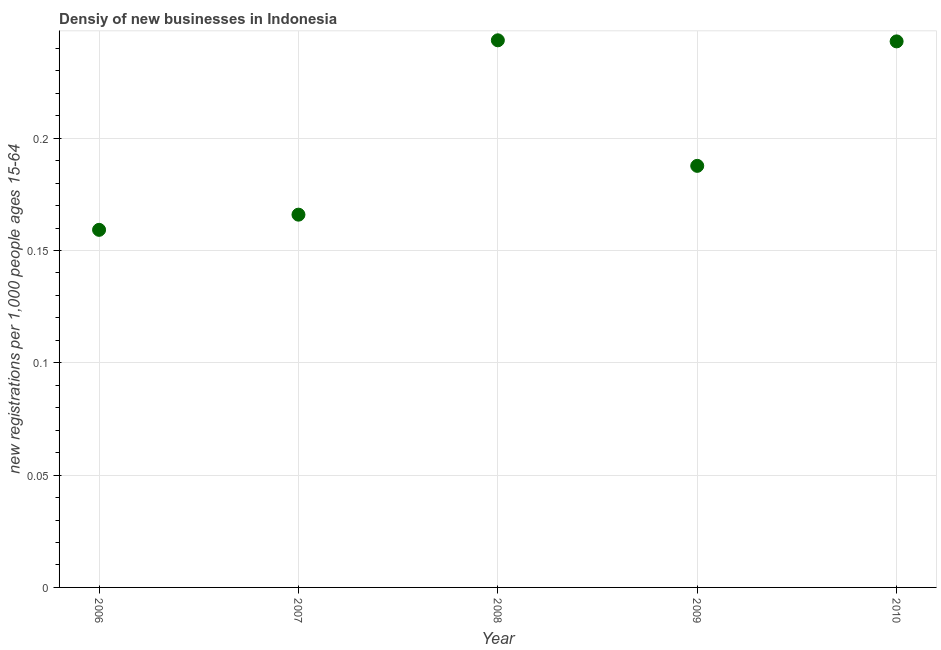What is the density of new business in 2010?
Your answer should be very brief. 0.24. Across all years, what is the maximum density of new business?
Provide a succinct answer. 0.24. Across all years, what is the minimum density of new business?
Keep it short and to the point. 0.16. In which year was the density of new business maximum?
Provide a succinct answer. 2008. What is the sum of the density of new business?
Make the answer very short. 1. What is the difference between the density of new business in 2006 and 2007?
Ensure brevity in your answer.  -0.01. What is the average density of new business per year?
Offer a very short reply. 0.2. What is the median density of new business?
Ensure brevity in your answer.  0.19. What is the ratio of the density of new business in 2007 to that in 2009?
Your answer should be compact. 0.88. Is the difference between the density of new business in 2006 and 2010 greater than the difference between any two years?
Ensure brevity in your answer.  No. What is the difference between the highest and the second highest density of new business?
Offer a terse response. 0. Is the sum of the density of new business in 2006 and 2010 greater than the maximum density of new business across all years?
Your response must be concise. Yes. What is the difference between the highest and the lowest density of new business?
Keep it short and to the point. 0.08. How many years are there in the graph?
Provide a succinct answer. 5. Are the values on the major ticks of Y-axis written in scientific E-notation?
Keep it short and to the point. No. Does the graph contain grids?
Offer a terse response. Yes. What is the title of the graph?
Your answer should be compact. Densiy of new businesses in Indonesia. What is the label or title of the X-axis?
Provide a short and direct response. Year. What is the label or title of the Y-axis?
Offer a terse response. New registrations per 1,0 people ages 15-64. What is the new registrations per 1,000 people ages 15-64 in 2006?
Provide a succinct answer. 0.16. What is the new registrations per 1,000 people ages 15-64 in 2007?
Your response must be concise. 0.17. What is the new registrations per 1,000 people ages 15-64 in 2008?
Your answer should be very brief. 0.24. What is the new registrations per 1,000 people ages 15-64 in 2009?
Provide a short and direct response. 0.19. What is the new registrations per 1,000 people ages 15-64 in 2010?
Give a very brief answer. 0.24. What is the difference between the new registrations per 1,000 people ages 15-64 in 2006 and 2007?
Keep it short and to the point. -0.01. What is the difference between the new registrations per 1,000 people ages 15-64 in 2006 and 2008?
Your answer should be compact. -0.08. What is the difference between the new registrations per 1,000 people ages 15-64 in 2006 and 2009?
Give a very brief answer. -0.03. What is the difference between the new registrations per 1,000 people ages 15-64 in 2006 and 2010?
Provide a succinct answer. -0.08. What is the difference between the new registrations per 1,000 people ages 15-64 in 2007 and 2008?
Provide a short and direct response. -0.08. What is the difference between the new registrations per 1,000 people ages 15-64 in 2007 and 2009?
Offer a very short reply. -0.02. What is the difference between the new registrations per 1,000 people ages 15-64 in 2007 and 2010?
Make the answer very short. -0.08. What is the difference between the new registrations per 1,000 people ages 15-64 in 2008 and 2009?
Keep it short and to the point. 0.06. What is the difference between the new registrations per 1,000 people ages 15-64 in 2008 and 2010?
Your response must be concise. 0. What is the difference between the new registrations per 1,000 people ages 15-64 in 2009 and 2010?
Ensure brevity in your answer.  -0.06. What is the ratio of the new registrations per 1,000 people ages 15-64 in 2006 to that in 2008?
Make the answer very short. 0.65. What is the ratio of the new registrations per 1,000 people ages 15-64 in 2006 to that in 2009?
Give a very brief answer. 0.85. What is the ratio of the new registrations per 1,000 people ages 15-64 in 2006 to that in 2010?
Your answer should be compact. 0.66. What is the ratio of the new registrations per 1,000 people ages 15-64 in 2007 to that in 2008?
Provide a short and direct response. 0.68. What is the ratio of the new registrations per 1,000 people ages 15-64 in 2007 to that in 2009?
Offer a very short reply. 0.88. What is the ratio of the new registrations per 1,000 people ages 15-64 in 2007 to that in 2010?
Your answer should be very brief. 0.68. What is the ratio of the new registrations per 1,000 people ages 15-64 in 2008 to that in 2009?
Provide a succinct answer. 1.3. What is the ratio of the new registrations per 1,000 people ages 15-64 in 2009 to that in 2010?
Keep it short and to the point. 0.77. 